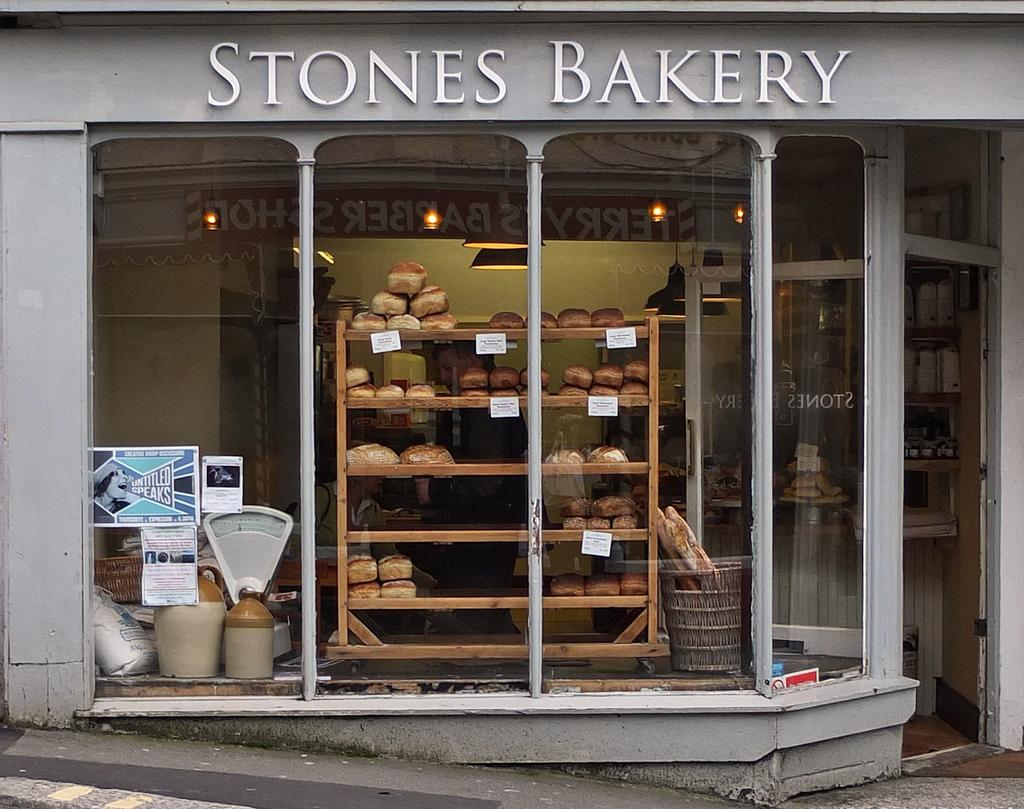What type of establishment is shown in the image? There is a store in the image. What can be seen on the wall inside the store? There is text on the wall in the image. What type of doors are present at the entrance of the store? There are glass doors in the image. What can be seen through the glass doors? Food items, objects, posters, and lights are visible through the glass doors. Are there any bats flying around inside the store in the image? There are no bats visible in the image; it shows a store with various items and text on the wall. 